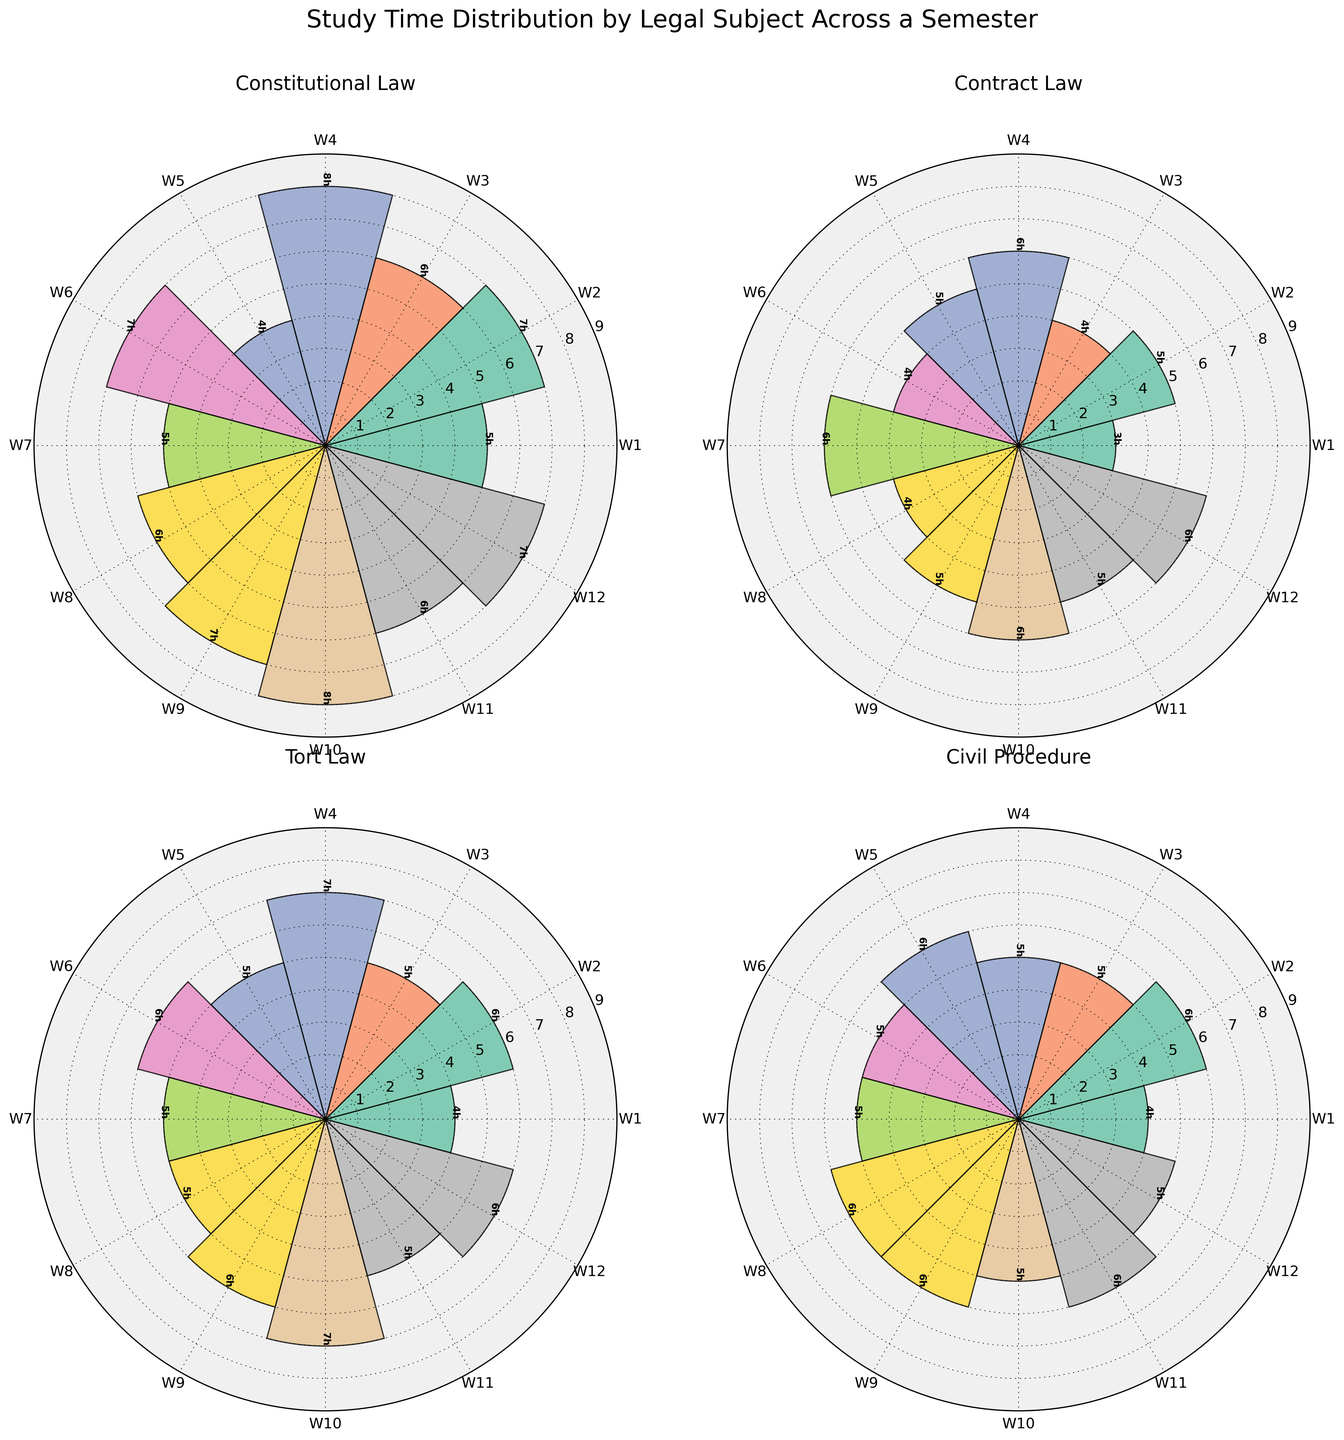How many weeks are represented in the figure? By looking at the labels on the bars, we can see there are 12 weeks represented.
Answer: 12 Which subject had the highest study hours in Week 4? We need to look at Week 4 for all the subjects in the figure. Constitutional Law had 8 hours in Week 4, which is the highest.
Answer: Constitutional Law What is the average study time for Contract Law over the semester? Sum the hours for Contract Law (3+5+4+6+5+4+6+4+5+6+5+6) = 59 hours, then divide by the number of weeks (12). So, 59/12 ≈ 4.92 hours.
Answer: ~4.92 hours Which subject has the most consistent study hours throughout the semester? We need to look at the variation in the bar heights for each subject. Civil Procedure has bars that are very similar in height, indicating the most consistent study hours.
Answer: Civil Procedure In which week did Tort Law and Civil Procedure have the same study hours? We compare the corresponding bars of Tort Law and Civil Procedure. In Week 12, both have 6 hours.
Answer: Week 12 What is the difference in the maximum study hours between Constitutional Law and Civil Procedure? Maximum hours for Constitutional Law is 8, and for Civil Procedure is 6. The difference is 8 - 6 = 2 hours.
Answer: 2 hours How many more hours were studied for Constitutional Law compared to Tort Law in Week 10? Week 10 hours for Constitutional Law = 8; for Tort Law = 7. The difference is 8 - 7 = 1 hour.
Answer: 1 hour Which subject shows the largest range of study hours across the semester? We need to find the range for each subject (max - min). For Constitutional Law, it's 8 - 4 = 4 hours. For Contract Law, it's 6 - 3 = 3 hours. For Tort Law, it's 7 - 4 = 3 hours. For Civil Procedure, it's 6 - 4 = 2 hours. So the largest range is for Constitutional Law.
Answer: Constitutional Law 